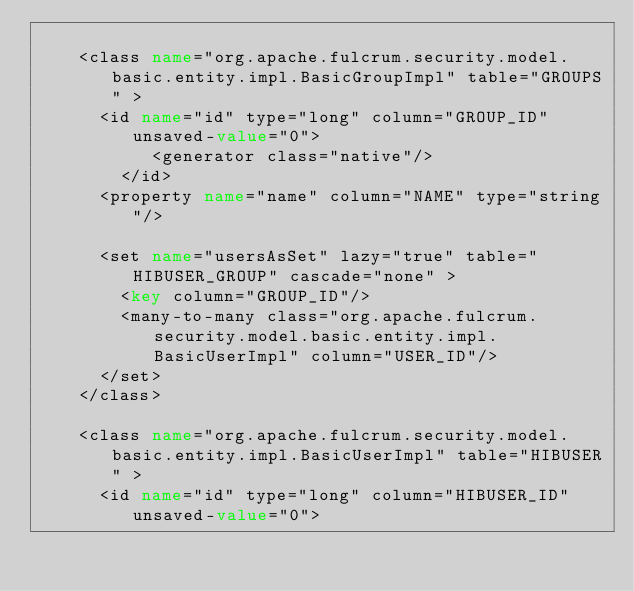Convert code to text. <code><loc_0><loc_0><loc_500><loc_500><_XML_>
    <class name="org.apache.fulcrum.security.model.basic.entity.impl.BasicGroupImpl" table="GROUPS" >
      <id name="id" type="long" column="GROUP_ID" unsaved-value="0">
           <generator class="native"/>
        </id>
      <property name="name" column="NAME" type="string"/>

      <set name="usersAsSet" lazy="true" table="HIBUSER_GROUP" cascade="none" >
        <key column="GROUP_ID"/>
        <many-to-many class="org.apache.fulcrum.security.model.basic.entity.impl.BasicUserImpl" column="USER_ID"/>
      </set>
    </class>

    <class name="org.apache.fulcrum.security.model.basic.entity.impl.BasicUserImpl" table="HIBUSER" >
      <id name="id" type="long" column="HIBUSER_ID" unsaved-value="0"></code> 